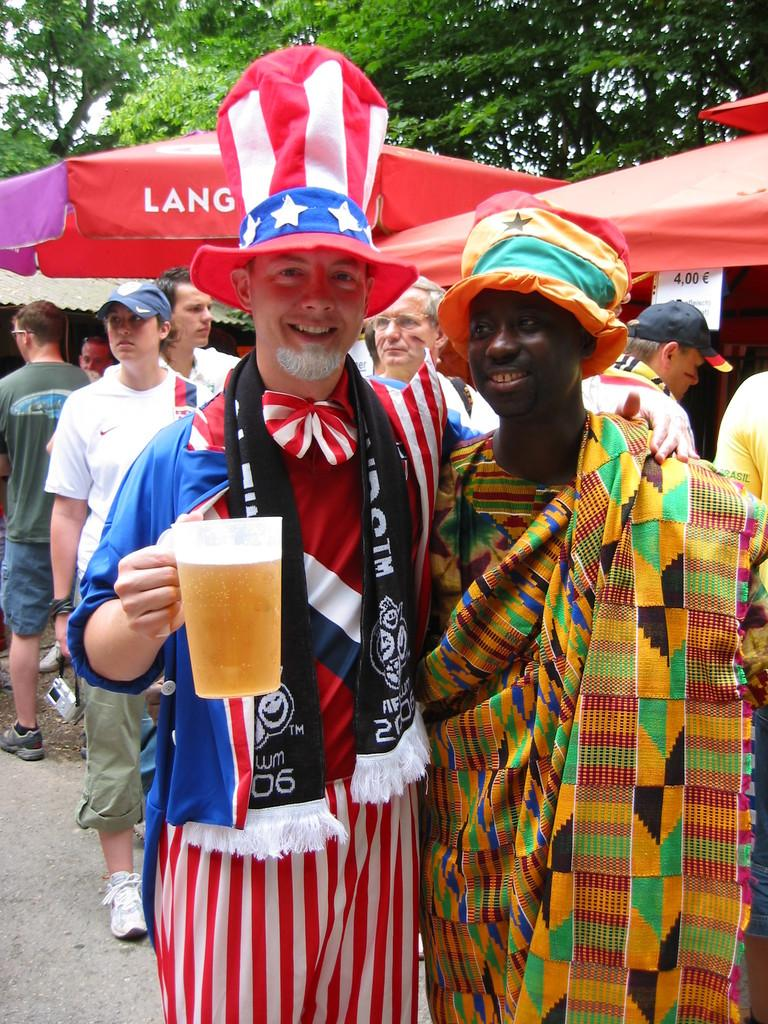<image>
Present a compact description of the photo's key features. a man in red white and blue stands with man in front of LANG umbrella 